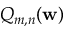<formula> <loc_0><loc_0><loc_500><loc_500>Q _ { m , n } ( w )</formula> 